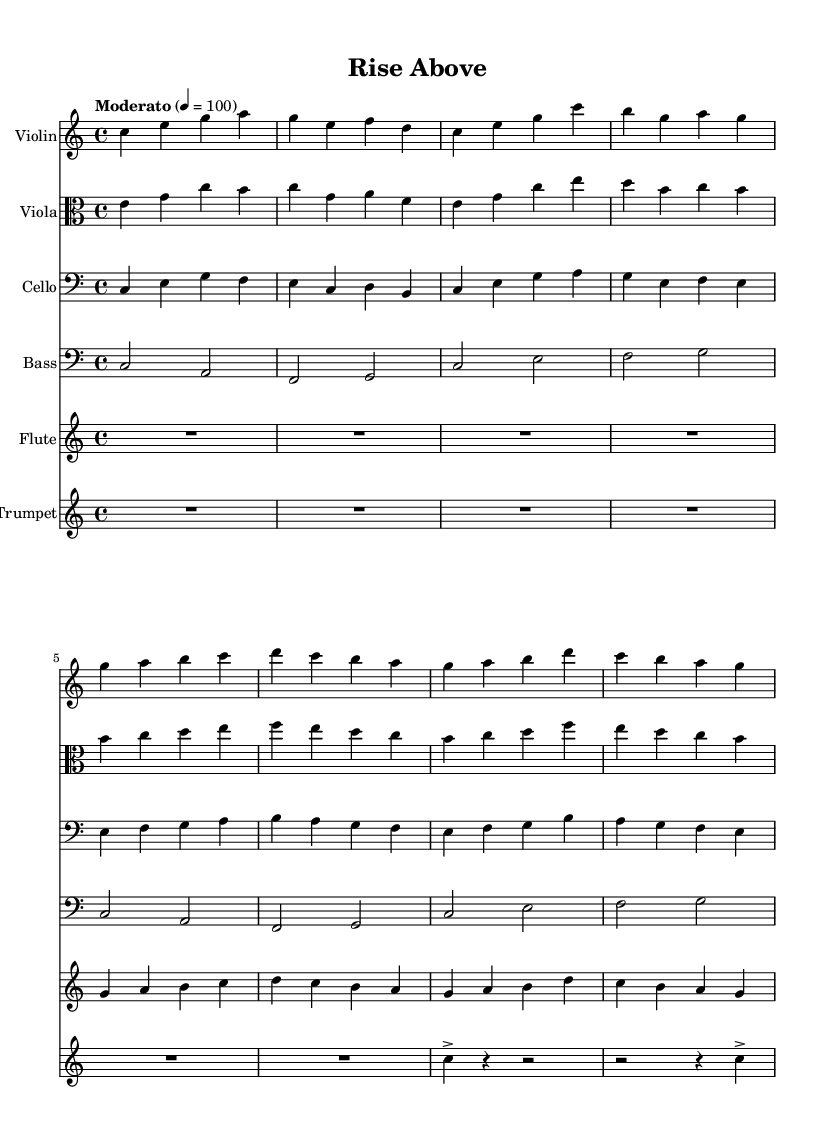what is the key signature of this music? The key signature is C major, which has no sharps or flats.
Answer: C major what is the time signature of this music? The time signature shown at the beginning of the score indicates that there are four beats in a measure, represented as 4/4.
Answer: 4/4 what is the tempo marking for this piece? The tempo marking at the beginning of the score indicates that the piece should be played at a moderate speed of one hundred beats per minute.
Answer: Moderato, 4 = 100 how many different instruments are present in the score? By counting the individual staves for each instrument, we see there are six distinct instruments specified in the score: Violin, Viola, Cello, Bass, Flute, and Trumpet.
Answer: Six which instrument plays the highest part in the score? Comparing the written notes in the staves, the Violin has the highest pitch range throughout the piece.
Answer: Violin what is the note value of the longest rest in the flute part? In the flute part, there is a whole note rest at the beginning which is represented as R1*4, indicating a full measure of silence.
Answer: Whole note how does the theme develop throughout the different instruments? The theme is presented by the Violin initially, and then echoed and expanded upon in the Viola and Flute, showing a collaborative variation of the main melody across the orchestra.
Answer: Through collaboration and variation 